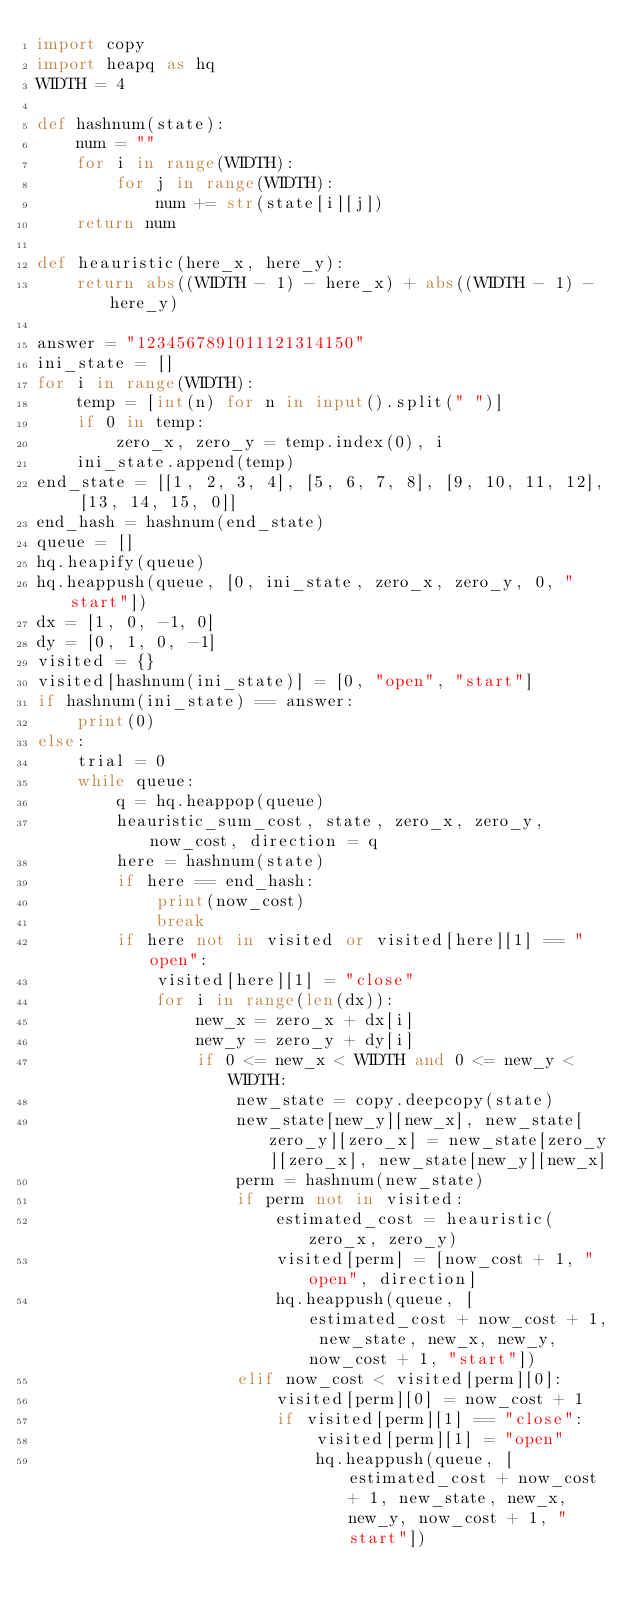Convert code to text. <code><loc_0><loc_0><loc_500><loc_500><_Python_>import copy
import heapq as hq
WIDTH = 4

def hashnum(state):
    num = ""
    for i in range(WIDTH):
        for j in range(WIDTH):
            num += str(state[i][j])
    return num

def heauristic(here_x, here_y):
    return abs((WIDTH - 1) - here_x) + abs((WIDTH - 1) - here_y)

answer = "1234567891011121314150"
ini_state = []
for i in range(WIDTH):
    temp = [int(n) for n in input().split(" ")]
    if 0 in temp:
        zero_x, zero_y = temp.index(0), i
    ini_state.append(temp)
end_state = [[1, 2, 3, 4], [5, 6, 7, 8], [9, 10, 11, 12], [13, 14, 15, 0]]
end_hash = hashnum(end_state)
queue = []
hq.heapify(queue)
hq.heappush(queue, [0, ini_state, zero_x, zero_y, 0, "start"])
dx = [1, 0, -1, 0]
dy = [0, 1, 0, -1]
visited = {}
visited[hashnum(ini_state)] = [0, "open", "start"]
if hashnum(ini_state) == answer:
    print(0)
else:
    trial = 0
    while queue:
        q = hq.heappop(queue)
        heauristic_sum_cost, state, zero_x, zero_y, now_cost, direction = q
        here = hashnum(state)
        if here == end_hash:
            print(now_cost)
            break
        if here not in visited or visited[here][1] == "open":
            visited[here][1] = "close"
            for i in range(len(dx)):
                new_x = zero_x + dx[i]
                new_y = zero_y + dy[i]
                if 0 <= new_x < WIDTH and 0 <= new_y < WIDTH:
                    new_state = copy.deepcopy(state)
                    new_state[new_y][new_x], new_state[zero_y][zero_x] = new_state[zero_y][zero_x], new_state[new_y][new_x]
                    perm = hashnum(new_state)
                    if perm not in visited:
                        estimated_cost = heauristic(zero_x, zero_y)
                        visited[perm] = [now_cost + 1, "open", direction]
                        hq.heappush(queue, [estimated_cost + now_cost + 1, new_state, new_x, new_y, now_cost + 1, "start"])
                    elif now_cost < visited[perm][0]:
                        visited[perm][0] = now_cost + 1
                        if visited[perm][1] == "close":
                            visited[perm][1] = "open"
                            hq.heappush(queue, [estimated_cost + now_cost + 1, new_state, new_x, new_y, now_cost + 1, "start"])</code> 